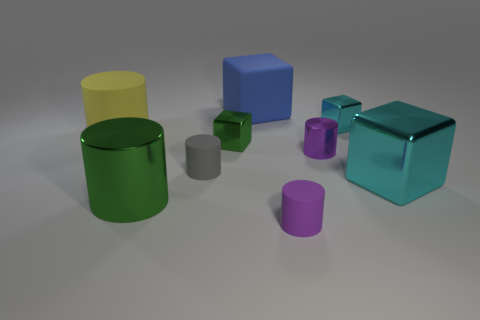Is the size of the cyan cube that is in front of the gray matte cylinder the same as the tiny purple shiny cylinder?
Provide a succinct answer. No. There is a large green object; how many things are behind it?
Your answer should be compact. 7. Is there a red cylinder that has the same size as the blue rubber object?
Your answer should be compact. No. Is the color of the big rubber block the same as the big metallic cylinder?
Ensure brevity in your answer.  No. The big block that is in front of the rubber cylinder that is behind the small green thing is what color?
Your answer should be very brief. Cyan. How many matte cylinders are in front of the big yellow rubber thing and behind the purple rubber thing?
Provide a succinct answer. 1. How many blue rubber objects have the same shape as the small gray rubber object?
Offer a terse response. 0. Are the blue object and the large yellow cylinder made of the same material?
Your response must be concise. Yes. What is the shape of the purple object that is to the left of the cylinder right of the small purple rubber cylinder?
Provide a short and direct response. Cylinder. There is a matte cylinder that is to the right of the big blue cube; how many tiny cubes are behind it?
Provide a short and direct response. 2. 